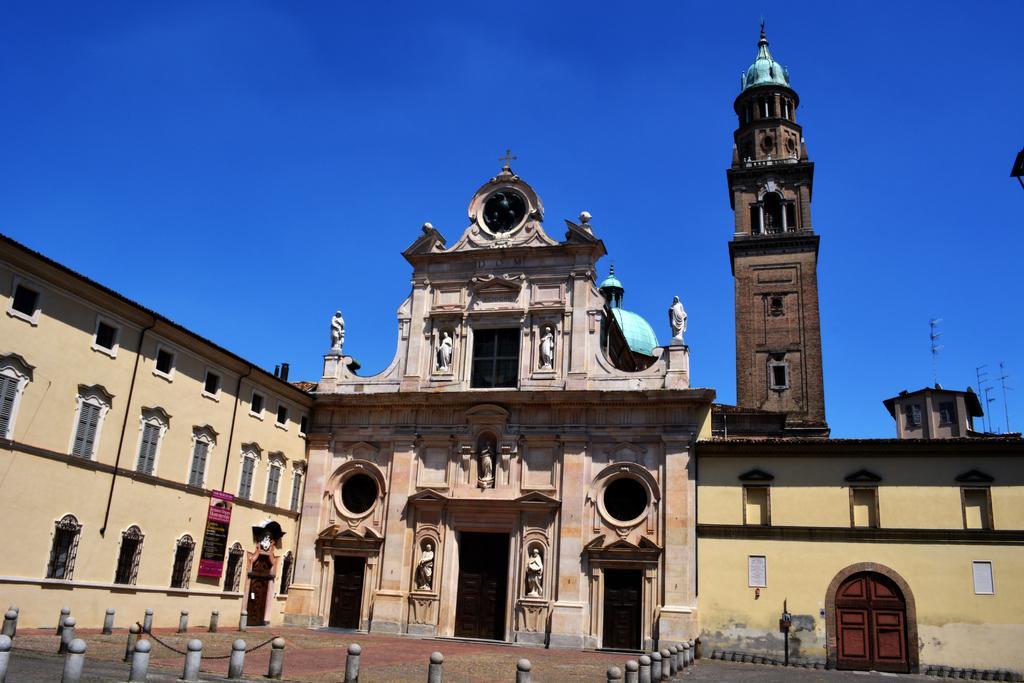How would you summarize this image in a sentence or two? In this image we can see the church, tower and some poles, some barrier rods on the path. We can also see the banner with the text. In the background there is sky. 